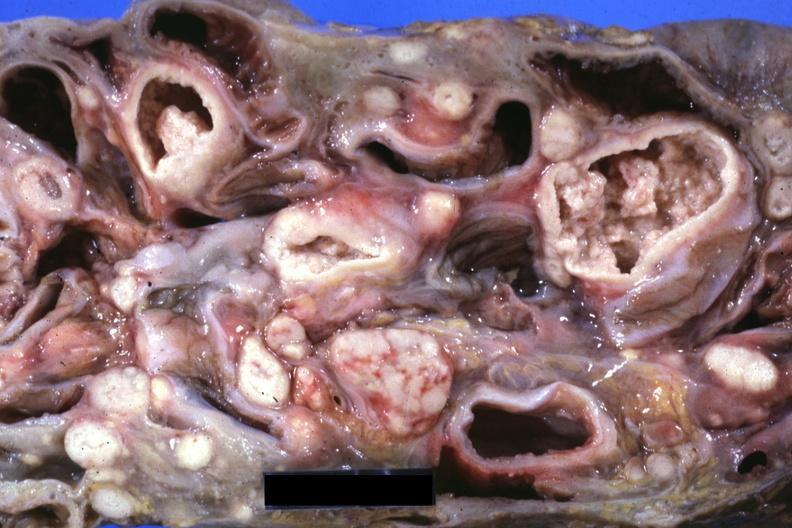how does this image show slice?
Answer the question using a single word or phrase. Through mass of intestines and mesenteric nodes showing lesions that look more like carcinoma but are in fact tuberculosis 